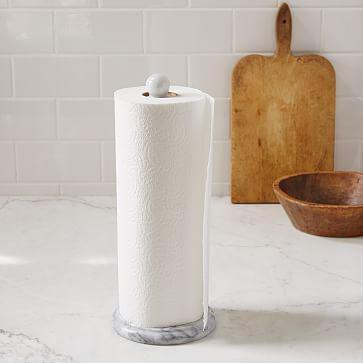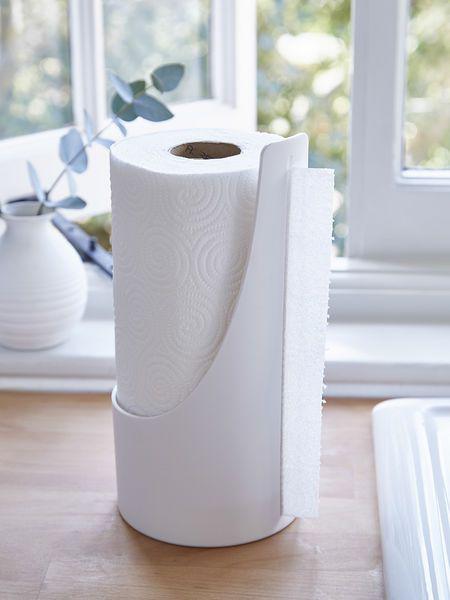The first image is the image on the left, the second image is the image on the right. Analyze the images presented: Is the assertion "An image shows one white paper towel roll on a stand with a post that sticks out at the top." valid? Answer yes or no. Yes. The first image is the image on the left, the second image is the image on the right. Evaluate the accuracy of this statement regarding the images: "At least one image shows a dispenser that is designed to be hung on the wall and fits rectangular napkins.". Is it true? Answer yes or no. No. 